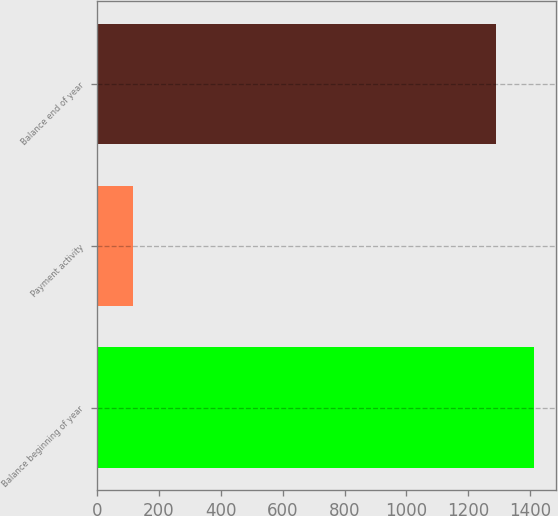Convert chart to OTSL. <chart><loc_0><loc_0><loc_500><loc_500><bar_chart><fcel>Balance beginning of year<fcel>Payment activity<fcel>Balance end of year<nl><fcel>1412.9<fcel>115<fcel>1290<nl></chart> 